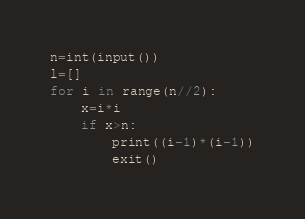Convert code to text. <code><loc_0><loc_0><loc_500><loc_500><_Python_>n=int(input())
l=[]
for i in range(n//2):
    x=i*i
    if x>n:
        print((i-1)*(i-1))
        exit()
</code> 